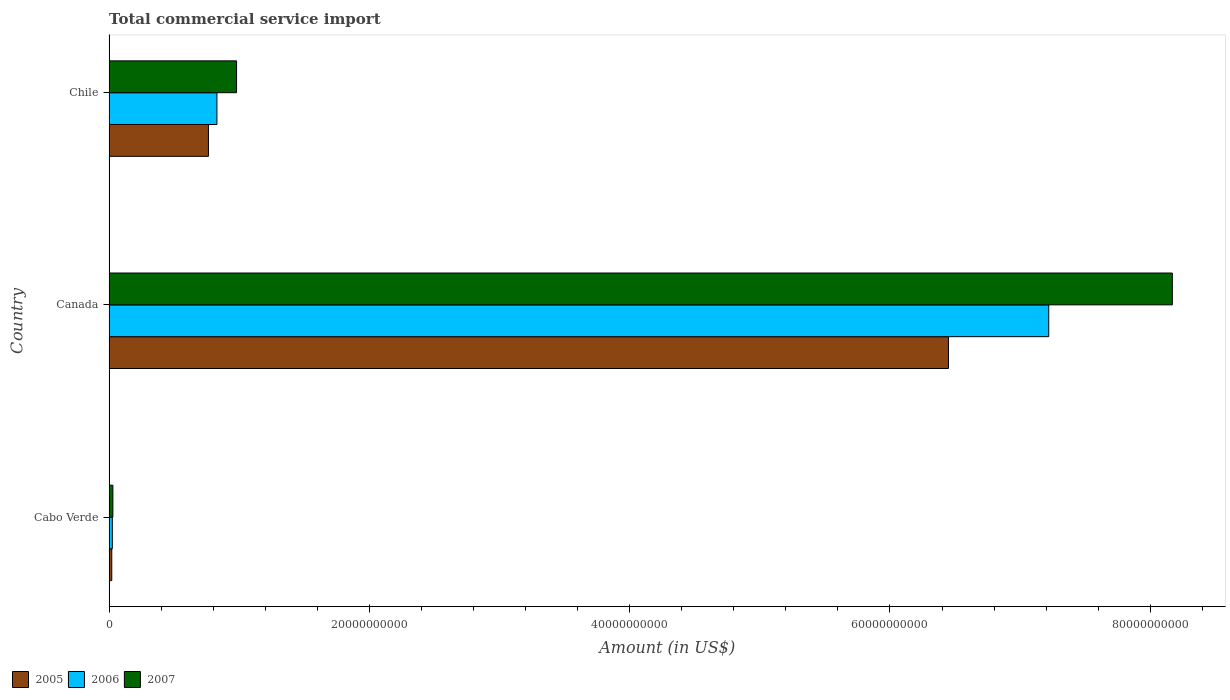What is the label of the 2nd group of bars from the top?
Offer a very short reply. Canada. In how many cases, is the number of bars for a given country not equal to the number of legend labels?
Your answer should be compact. 0. What is the total commercial service import in 2006 in Cabo Verde?
Offer a terse response. 2.51e+08. Across all countries, what is the maximum total commercial service import in 2005?
Keep it short and to the point. 6.45e+1. Across all countries, what is the minimum total commercial service import in 2005?
Make the answer very short. 2.07e+08. In which country was the total commercial service import in 2005 minimum?
Give a very brief answer. Cabo Verde. What is the total total commercial service import in 2006 in the graph?
Provide a succinct answer. 8.07e+1. What is the difference between the total commercial service import in 2007 in Cabo Verde and that in Chile?
Offer a terse response. -9.50e+09. What is the difference between the total commercial service import in 2005 in Chile and the total commercial service import in 2007 in Cabo Verde?
Ensure brevity in your answer.  7.34e+09. What is the average total commercial service import in 2005 per country?
Make the answer very short. 2.41e+1. What is the difference between the total commercial service import in 2006 and total commercial service import in 2007 in Chile?
Your response must be concise. -1.51e+09. What is the ratio of the total commercial service import in 2005 in Cabo Verde to that in Chile?
Your answer should be very brief. 0.03. Is the difference between the total commercial service import in 2006 in Canada and Chile greater than the difference between the total commercial service import in 2007 in Canada and Chile?
Provide a short and direct response. No. What is the difference between the highest and the second highest total commercial service import in 2006?
Keep it short and to the point. 6.39e+1. What is the difference between the highest and the lowest total commercial service import in 2007?
Provide a succinct answer. 8.14e+1. Is the sum of the total commercial service import in 2007 in Canada and Chile greater than the maximum total commercial service import in 2006 across all countries?
Offer a very short reply. Yes. What does the 1st bar from the bottom in Cabo Verde represents?
Make the answer very short. 2005. How many bars are there?
Your answer should be very brief. 9. Are all the bars in the graph horizontal?
Your answer should be compact. Yes. Does the graph contain grids?
Offer a terse response. No. Where does the legend appear in the graph?
Give a very brief answer. Bottom left. What is the title of the graph?
Provide a succinct answer. Total commercial service import. What is the label or title of the X-axis?
Provide a succinct answer. Amount (in US$). What is the Amount (in US$) in 2005 in Cabo Verde?
Keep it short and to the point. 2.07e+08. What is the Amount (in US$) of 2006 in Cabo Verde?
Make the answer very short. 2.51e+08. What is the Amount (in US$) in 2007 in Cabo Verde?
Your answer should be compact. 2.92e+08. What is the Amount (in US$) in 2005 in Canada?
Your answer should be very brief. 6.45e+1. What is the Amount (in US$) in 2006 in Canada?
Ensure brevity in your answer.  7.22e+1. What is the Amount (in US$) in 2007 in Canada?
Ensure brevity in your answer.  8.17e+1. What is the Amount (in US$) in 2005 in Chile?
Keep it short and to the point. 7.63e+09. What is the Amount (in US$) of 2006 in Chile?
Offer a terse response. 8.29e+09. What is the Amount (in US$) in 2007 in Chile?
Provide a succinct answer. 9.80e+09. Across all countries, what is the maximum Amount (in US$) in 2005?
Keep it short and to the point. 6.45e+1. Across all countries, what is the maximum Amount (in US$) of 2006?
Make the answer very short. 7.22e+1. Across all countries, what is the maximum Amount (in US$) of 2007?
Your answer should be compact. 8.17e+1. Across all countries, what is the minimum Amount (in US$) of 2005?
Offer a very short reply. 2.07e+08. Across all countries, what is the minimum Amount (in US$) in 2006?
Provide a short and direct response. 2.51e+08. Across all countries, what is the minimum Amount (in US$) of 2007?
Make the answer very short. 2.92e+08. What is the total Amount (in US$) in 2005 in the graph?
Make the answer very short. 7.23e+1. What is the total Amount (in US$) in 2006 in the graph?
Ensure brevity in your answer.  8.07e+1. What is the total Amount (in US$) in 2007 in the graph?
Offer a terse response. 9.18e+1. What is the difference between the Amount (in US$) in 2005 in Cabo Verde and that in Canada?
Give a very brief answer. -6.43e+1. What is the difference between the Amount (in US$) in 2006 in Cabo Verde and that in Canada?
Make the answer very short. -7.19e+1. What is the difference between the Amount (in US$) of 2007 in Cabo Verde and that in Canada?
Make the answer very short. -8.14e+1. What is the difference between the Amount (in US$) of 2005 in Cabo Verde and that in Chile?
Make the answer very short. -7.43e+09. What is the difference between the Amount (in US$) in 2006 in Cabo Verde and that in Chile?
Keep it short and to the point. -8.04e+09. What is the difference between the Amount (in US$) in 2007 in Cabo Verde and that in Chile?
Ensure brevity in your answer.  -9.50e+09. What is the difference between the Amount (in US$) in 2005 in Canada and that in Chile?
Keep it short and to the point. 5.69e+1. What is the difference between the Amount (in US$) of 2006 in Canada and that in Chile?
Provide a succinct answer. 6.39e+1. What is the difference between the Amount (in US$) of 2007 in Canada and that in Chile?
Provide a succinct answer. 7.19e+1. What is the difference between the Amount (in US$) in 2005 in Cabo Verde and the Amount (in US$) in 2006 in Canada?
Your answer should be compact. -7.20e+1. What is the difference between the Amount (in US$) of 2005 in Cabo Verde and the Amount (in US$) of 2007 in Canada?
Your response must be concise. -8.15e+1. What is the difference between the Amount (in US$) in 2006 in Cabo Verde and the Amount (in US$) in 2007 in Canada?
Offer a terse response. -8.14e+1. What is the difference between the Amount (in US$) in 2005 in Cabo Verde and the Amount (in US$) in 2006 in Chile?
Ensure brevity in your answer.  -8.08e+09. What is the difference between the Amount (in US$) of 2005 in Cabo Verde and the Amount (in US$) of 2007 in Chile?
Give a very brief answer. -9.59e+09. What is the difference between the Amount (in US$) of 2006 in Cabo Verde and the Amount (in US$) of 2007 in Chile?
Your response must be concise. -9.55e+09. What is the difference between the Amount (in US$) in 2005 in Canada and the Amount (in US$) in 2006 in Chile?
Offer a very short reply. 5.62e+1. What is the difference between the Amount (in US$) of 2005 in Canada and the Amount (in US$) of 2007 in Chile?
Offer a very short reply. 5.47e+1. What is the difference between the Amount (in US$) of 2006 in Canada and the Amount (in US$) of 2007 in Chile?
Provide a succinct answer. 6.24e+1. What is the average Amount (in US$) in 2005 per country?
Your answer should be very brief. 2.41e+1. What is the average Amount (in US$) in 2006 per country?
Provide a short and direct response. 2.69e+1. What is the average Amount (in US$) of 2007 per country?
Offer a very short reply. 3.06e+1. What is the difference between the Amount (in US$) in 2005 and Amount (in US$) in 2006 in Cabo Verde?
Ensure brevity in your answer.  -4.40e+07. What is the difference between the Amount (in US$) in 2005 and Amount (in US$) in 2007 in Cabo Verde?
Ensure brevity in your answer.  -8.51e+07. What is the difference between the Amount (in US$) in 2006 and Amount (in US$) in 2007 in Cabo Verde?
Keep it short and to the point. -4.12e+07. What is the difference between the Amount (in US$) of 2005 and Amount (in US$) of 2006 in Canada?
Ensure brevity in your answer.  -7.70e+09. What is the difference between the Amount (in US$) of 2005 and Amount (in US$) of 2007 in Canada?
Offer a very short reply. -1.72e+1. What is the difference between the Amount (in US$) in 2006 and Amount (in US$) in 2007 in Canada?
Your answer should be compact. -9.50e+09. What is the difference between the Amount (in US$) in 2005 and Amount (in US$) in 2006 in Chile?
Your answer should be compact. -6.52e+08. What is the difference between the Amount (in US$) of 2005 and Amount (in US$) of 2007 in Chile?
Provide a short and direct response. -2.16e+09. What is the difference between the Amount (in US$) of 2006 and Amount (in US$) of 2007 in Chile?
Make the answer very short. -1.51e+09. What is the ratio of the Amount (in US$) of 2005 in Cabo Verde to that in Canada?
Provide a short and direct response. 0. What is the ratio of the Amount (in US$) of 2006 in Cabo Verde to that in Canada?
Give a very brief answer. 0. What is the ratio of the Amount (in US$) in 2007 in Cabo Verde to that in Canada?
Your answer should be compact. 0. What is the ratio of the Amount (in US$) of 2005 in Cabo Verde to that in Chile?
Offer a terse response. 0.03. What is the ratio of the Amount (in US$) of 2006 in Cabo Verde to that in Chile?
Make the answer very short. 0.03. What is the ratio of the Amount (in US$) of 2007 in Cabo Verde to that in Chile?
Provide a succinct answer. 0.03. What is the ratio of the Amount (in US$) in 2005 in Canada to that in Chile?
Offer a terse response. 8.45. What is the ratio of the Amount (in US$) in 2006 in Canada to that in Chile?
Your answer should be compact. 8.71. What is the ratio of the Amount (in US$) of 2007 in Canada to that in Chile?
Offer a terse response. 8.34. What is the difference between the highest and the second highest Amount (in US$) in 2005?
Give a very brief answer. 5.69e+1. What is the difference between the highest and the second highest Amount (in US$) of 2006?
Offer a very short reply. 6.39e+1. What is the difference between the highest and the second highest Amount (in US$) of 2007?
Offer a very short reply. 7.19e+1. What is the difference between the highest and the lowest Amount (in US$) in 2005?
Keep it short and to the point. 6.43e+1. What is the difference between the highest and the lowest Amount (in US$) in 2006?
Make the answer very short. 7.19e+1. What is the difference between the highest and the lowest Amount (in US$) of 2007?
Your answer should be very brief. 8.14e+1. 